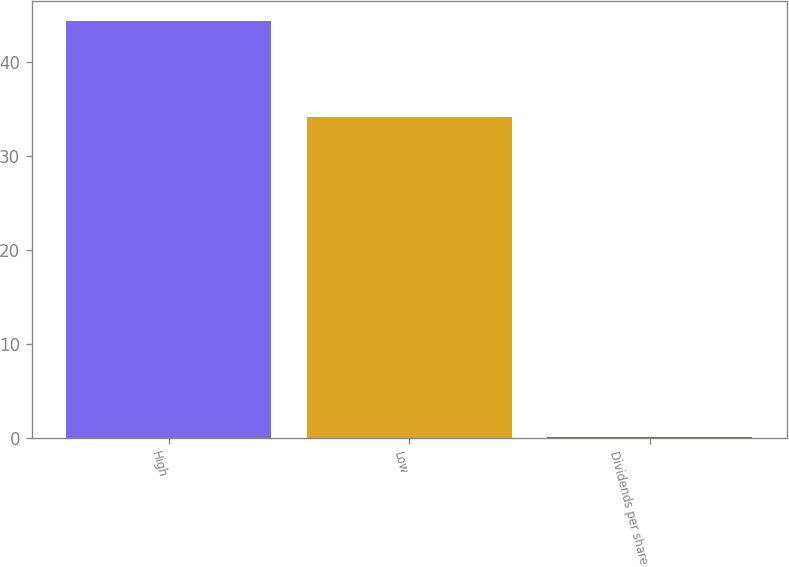Convert chart. <chart><loc_0><loc_0><loc_500><loc_500><bar_chart><fcel>High<fcel>Low<fcel>Dividends per share<nl><fcel>44.34<fcel>34.16<fcel>0.1<nl></chart> 